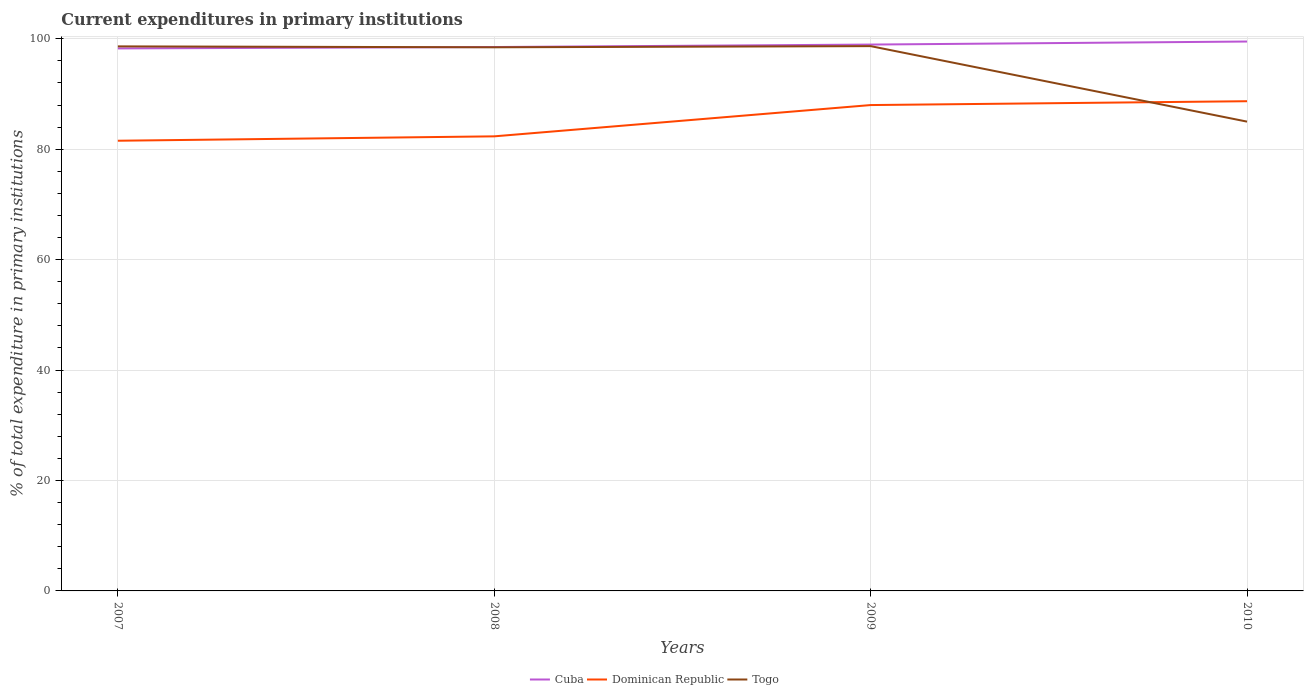Across all years, what is the maximum current expenditures in primary institutions in Cuba?
Your response must be concise. 98.26. What is the total current expenditures in primary institutions in Cuba in the graph?
Your response must be concise. -0.25. What is the difference between the highest and the second highest current expenditures in primary institutions in Dominican Republic?
Your answer should be very brief. 7.16. Is the current expenditures in primary institutions in Cuba strictly greater than the current expenditures in primary institutions in Togo over the years?
Provide a succinct answer. No. How many lines are there?
Give a very brief answer. 3. Where does the legend appear in the graph?
Give a very brief answer. Bottom center. How many legend labels are there?
Keep it short and to the point. 3. How are the legend labels stacked?
Your answer should be very brief. Horizontal. What is the title of the graph?
Make the answer very short. Current expenditures in primary institutions. What is the label or title of the Y-axis?
Offer a terse response. % of total expenditure in primary institutions. What is the % of total expenditure in primary institutions of Cuba in 2007?
Your response must be concise. 98.26. What is the % of total expenditure in primary institutions in Dominican Republic in 2007?
Make the answer very short. 81.54. What is the % of total expenditure in primary institutions in Togo in 2007?
Offer a terse response. 98.63. What is the % of total expenditure in primary institutions in Cuba in 2008?
Provide a short and direct response. 98.51. What is the % of total expenditure in primary institutions in Dominican Republic in 2008?
Your answer should be compact. 82.33. What is the % of total expenditure in primary institutions in Togo in 2008?
Provide a short and direct response. 98.46. What is the % of total expenditure in primary institutions in Cuba in 2009?
Make the answer very short. 98.96. What is the % of total expenditure in primary institutions in Dominican Republic in 2009?
Make the answer very short. 88. What is the % of total expenditure in primary institutions of Togo in 2009?
Make the answer very short. 98.67. What is the % of total expenditure in primary institutions in Cuba in 2010?
Provide a short and direct response. 99.5. What is the % of total expenditure in primary institutions in Dominican Republic in 2010?
Make the answer very short. 88.69. What is the % of total expenditure in primary institutions in Togo in 2010?
Provide a short and direct response. 85. Across all years, what is the maximum % of total expenditure in primary institutions of Cuba?
Your answer should be compact. 99.5. Across all years, what is the maximum % of total expenditure in primary institutions in Dominican Republic?
Your response must be concise. 88.69. Across all years, what is the maximum % of total expenditure in primary institutions in Togo?
Make the answer very short. 98.67. Across all years, what is the minimum % of total expenditure in primary institutions of Cuba?
Provide a succinct answer. 98.26. Across all years, what is the minimum % of total expenditure in primary institutions of Dominican Republic?
Offer a very short reply. 81.54. Across all years, what is the minimum % of total expenditure in primary institutions of Togo?
Give a very brief answer. 85. What is the total % of total expenditure in primary institutions in Cuba in the graph?
Offer a very short reply. 395.23. What is the total % of total expenditure in primary institutions of Dominican Republic in the graph?
Offer a terse response. 340.56. What is the total % of total expenditure in primary institutions of Togo in the graph?
Your answer should be very brief. 380.76. What is the difference between the % of total expenditure in primary institutions of Cuba in 2007 and that in 2008?
Provide a short and direct response. -0.25. What is the difference between the % of total expenditure in primary institutions in Dominican Republic in 2007 and that in 2008?
Ensure brevity in your answer.  -0.8. What is the difference between the % of total expenditure in primary institutions in Togo in 2007 and that in 2008?
Offer a very short reply. 0.17. What is the difference between the % of total expenditure in primary institutions of Cuba in 2007 and that in 2009?
Ensure brevity in your answer.  -0.7. What is the difference between the % of total expenditure in primary institutions in Dominican Republic in 2007 and that in 2009?
Provide a short and direct response. -6.46. What is the difference between the % of total expenditure in primary institutions of Togo in 2007 and that in 2009?
Your answer should be compact. -0.04. What is the difference between the % of total expenditure in primary institutions of Cuba in 2007 and that in 2010?
Offer a terse response. -1.25. What is the difference between the % of total expenditure in primary institutions in Dominican Republic in 2007 and that in 2010?
Your response must be concise. -7.16. What is the difference between the % of total expenditure in primary institutions of Togo in 2007 and that in 2010?
Your answer should be compact. 13.63. What is the difference between the % of total expenditure in primary institutions of Cuba in 2008 and that in 2009?
Provide a short and direct response. -0.45. What is the difference between the % of total expenditure in primary institutions in Dominican Republic in 2008 and that in 2009?
Provide a short and direct response. -5.67. What is the difference between the % of total expenditure in primary institutions in Togo in 2008 and that in 2009?
Offer a terse response. -0.21. What is the difference between the % of total expenditure in primary institutions in Cuba in 2008 and that in 2010?
Offer a terse response. -0.99. What is the difference between the % of total expenditure in primary institutions of Dominican Republic in 2008 and that in 2010?
Your answer should be compact. -6.36. What is the difference between the % of total expenditure in primary institutions of Togo in 2008 and that in 2010?
Give a very brief answer. 13.46. What is the difference between the % of total expenditure in primary institutions of Cuba in 2009 and that in 2010?
Give a very brief answer. -0.55. What is the difference between the % of total expenditure in primary institutions in Dominican Republic in 2009 and that in 2010?
Your answer should be very brief. -0.7. What is the difference between the % of total expenditure in primary institutions in Togo in 2009 and that in 2010?
Make the answer very short. 13.67. What is the difference between the % of total expenditure in primary institutions of Cuba in 2007 and the % of total expenditure in primary institutions of Dominican Republic in 2008?
Offer a terse response. 15.93. What is the difference between the % of total expenditure in primary institutions of Cuba in 2007 and the % of total expenditure in primary institutions of Togo in 2008?
Provide a succinct answer. -0.2. What is the difference between the % of total expenditure in primary institutions of Dominican Republic in 2007 and the % of total expenditure in primary institutions of Togo in 2008?
Make the answer very short. -16.92. What is the difference between the % of total expenditure in primary institutions in Cuba in 2007 and the % of total expenditure in primary institutions in Dominican Republic in 2009?
Your answer should be compact. 10.26. What is the difference between the % of total expenditure in primary institutions in Cuba in 2007 and the % of total expenditure in primary institutions in Togo in 2009?
Ensure brevity in your answer.  -0.41. What is the difference between the % of total expenditure in primary institutions of Dominican Republic in 2007 and the % of total expenditure in primary institutions of Togo in 2009?
Give a very brief answer. -17.14. What is the difference between the % of total expenditure in primary institutions in Cuba in 2007 and the % of total expenditure in primary institutions in Dominican Republic in 2010?
Your response must be concise. 9.56. What is the difference between the % of total expenditure in primary institutions of Cuba in 2007 and the % of total expenditure in primary institutions of Togo in 2010?
Your answer should be compact. 13.26. What is the difference between the % of total expenditure in primary institutions in Dominican Republic in 2007 and the % of total expenditure in primary institutions in Togo in 2010?
Offer a terse response. -3.46. What is the difference between the % of total expenditure in primary institutions in Cuba in 2008 and the % of total expenditure in primary institutions in Dominican Republic in 2009?
Your answer should be compact. 10.51. What is the difference between the % of total expenditure in primary institutions of Cuba in 2008 and the % of total expenditure in primary institutions of Togo in 2009?
Offer a terse response. -0.16. What is the difference between the % of total expenditure in primary institutions in Dominican Republic in 2008 and the % of total expenditure in primary institutions in Togo in 2009?
Provide a succinct answer. -16.34. What is the difference between the % of total expenditure in primary institutions of Cuba in 2008 and the % of total expenditure in primary institutions of Dominican Republic in 2010?
Keep it short and to the point. 9.81. What is the difference between the % of total expenditure in primary institutions in Cuba in 2008 and the % of total expenditure in primary institutions in Togo in 2010?
Ensure brevity in your answer.  13.51. What is the difference between the % of total expenditure in primary institutions of Dominican Republic in 2008 and the % of total expenditure in primary institutions of Togo in 2010?
Ensure brevity in your answer.  -2.67. What is the difference between the % of total expenditure in primary institutions of Cuba in 2009 and the % of total expenditure in primary institutions of Dominican Republic in 2010?
Provide a short and direct response. 10.26. What is the difference between the % of total expenditure in primary institutions in Cuba in 2009 and the % of total expenditure in primary institutions in Togo in 2010?
Offer a very short reply. 13.96. What is the average % of total expenditure in primary institutions in Cuba per year?
Keep it short and to the point. 98.81. What is the average % of total expenditure in primary institutions in Dominican Republic per year?
Make the answer very short. 85.14. What is the average % of total expenditure in primary institutions in Togo per year?
Give a very brief answer. 95.19. In the year 2007, what is the difference between the % of total expenditure in primary institutions of Cuba and % of total expenditure in primary institutions of Dominican Republic?
Offer a terse response. 16.72. In the year 2007, what is the difference between the % of total expenditure in primary institutions of Cuba and % of total expenditure in primary institutions of Togo?
Your answer should be compact. -0.37. In the year 2007, what is the difference between the % of total expenditure in primary institutions of Dominican Republic and % of total expenditure in primary institutions of Togo?
Make the answer very short. -17.09. In the year 2008, what is the difference between the % of total expenditure in primary institutions of Cuba and % of total expenditure in primary institutions of Dominican Republic?
Give a very brief answer. 16.18. In the year 2008, what is the difference between the % of total expenditure in primary institutions of Cuba and % of total expenditure in primary institutions of Togo?
Offer a very short reply. 0.05. In the year 2008, what is the difference between the % of total expenditure in primary institutions of Dominican Republic and % of total expenditure in primary institutions of Togo?
Give a very brief answer. -16.13. In the year 2009, what is the difference between the % of total expenditure in primary institutions of Cuba and % of total expenditure in primary institutions of Dominican Republic?
Give a very brief answer. 10.96. In the year 2009, what is the difference between the % of total expenditure in primary institutions in Cuba and % of total expenditure in primary institutions in Togo?
Ensure brevity in your answer.  0.28. In the year 2009, what is the difference between the % of total expenditure in primary institutions of Dominican Republic and % of total expenditure in primary institutions of Togo?
Your answer should be very brief. -10.67. In the year 2010, what is the difference between the % of total expenditure in primary institutions in Cuba and % of total expenditure in primary institutions in Dominican Republic?
Make the answer very short. 10.81. In the year 2010, what is the difference between the % of total expenditure in primary institutions in Cuba and % of total expenditure in primary institutions in Togo?
Ensure brevity in your answer.  14.51. In the year 2010, what is the difference between the % of total expenditure in primary institutions of Dominican Republic and % of total expenditure in primary institutions of Togo?
Give a very brief answer. 3.7. What is the ratio of the % of total expenditure in primary institutions of Cuba in 2007 to that in 2008?
Your response must be concise. 1. What is the ratio of the % of total expenditure in primary institutions of Dominican Republic in 2007 to that in 2008?
Provide a succinct answer. 0.99. What is the ratio of the % of total expenditure in primary institutions in Togo in 2007 to that in 2008?
Offer a terse response. 1. What is the ratio of the % of total expenditure in primary institutions of Cuba in 2007 to that in 2009?
Offer a very short reply. 0.99. What is the ratio of the % of total expenditure in primary institutions of Dominican Republic in 2007 to that in 2009?
Keep it short and to the point. 0.93. What is the ratio of the % of total expenditure in primary institutions of Togo in 2007 to that in 2009?
Offer a very short reply. 1. What is the ratio of the % of total expenditure in primary institutions of Cuba in 2007 to that in 2010?
Offer a terse response. 0.99. What is the ratio of the % of total expenditure in primary institutions in Dominican Republic in 2007 to that in 2010?
Give a very brief answer. 0.92. What is the ratio of the % of total expenditure in primary institutions of Togo in 2007 to that in 2010?
Ensure brevity in your answer.  1.16. What is the ratio of the % of total expenditure in primary institutions of Dominican Republic in 2008 to that in 2009?
Provide a short and direct response. 0.94. What is the ratio of the % of total expenditure in primary institutions in Togo in 2008 to that in 2009?
Offer a very short reply. 1. What is the ratio of the % of total expenditure in primary institutions of Cuba in 2008 to that in 2010?
Provide a short and direct response. 0.99. What is the ratio of the % of total expenditure in primary institutions of Dominican Republic in 2008 to that in 2010?
Provide a short and direct response. 0.93. What is the ratio of the % of total expenditure in primary institutions of Togo in 2008 to that in 2010?
Offer a very short reply. 1.16. What is the ratio of the % of total expenditure in primary institutions in Cuba in 2009 to that in 2010?
Provide a short and direct response. 0.99. What is the ratio of the % of total expenditure in primary institutions in Togo in 2009 to that in 2010?
Offer a very short reply. 1.16. What is the difference between the highest and the second highest % of total expenditure in primary institutions of Cuba?
Give a very brief answer. 0.55. What is the difference between the highest and the second highest % of total expenditure in primary institutions in Dominican Republic?
Provide a short and direct response. 0.7. What is the difference between the highest and the second highest % of total expenditure in primary institutions of Togo?
Provide a succinct answer. 0.04. What is the difference between the highest and the lowest % of total expenditure in primary institutions in Cuba?
Offer a terse response. 1.25. What is the difference between the highest and the lowest % of total expenditure in primary institutions in Dominican Republic?
Make the answer very short. 7.16. What is the difference between the highest and the lowest % of total expenditure in primary institutions of Togo?
Provide a short and direct response. 13.67. 